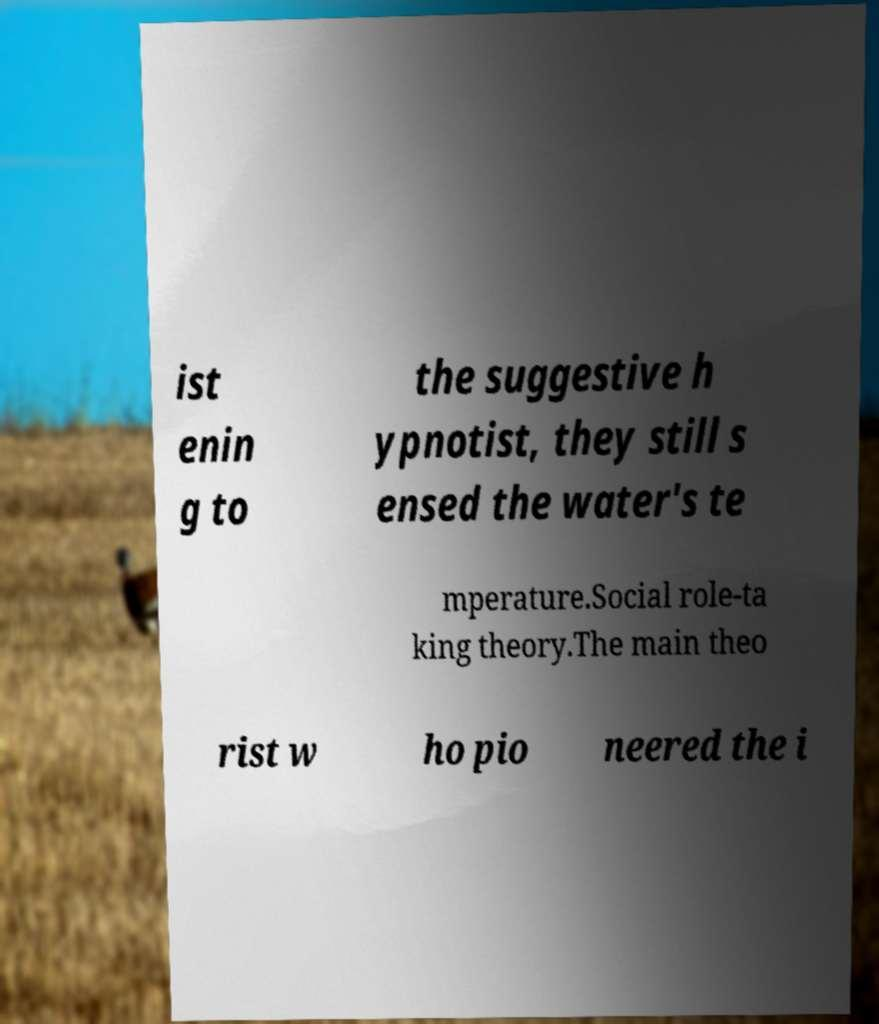Could you assist in decoding the text presented in this image and type it out clearly? ist enin g to the suggestive h ypnotist, they still s ensed the water's te mperature.Social role-ta king theory.The main theo rist w ho pio neered the i 